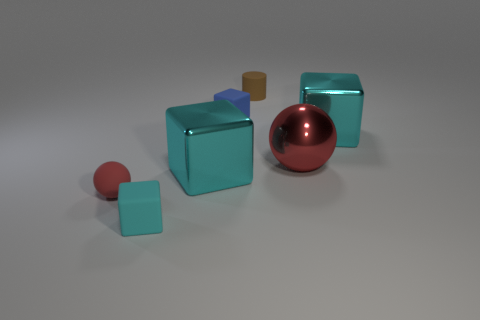Subtract all gray cylinders. How many cyan blocks are left? 3 Add 1 small cylinders. How many objects exist? 8 Subtract all blocks. How many objects are left? 3 Add 6 big cyan shiny blocks. How many big cyan shiny blocks are left? 8 Add 1 blue metal objects. How many blue metal objects exist? 1 Subtract 0 yellow cylinders. How many objects are left? 7 Subtract all yellow cubes. Subtract all small red matte spheres. How many objects are left? 6 